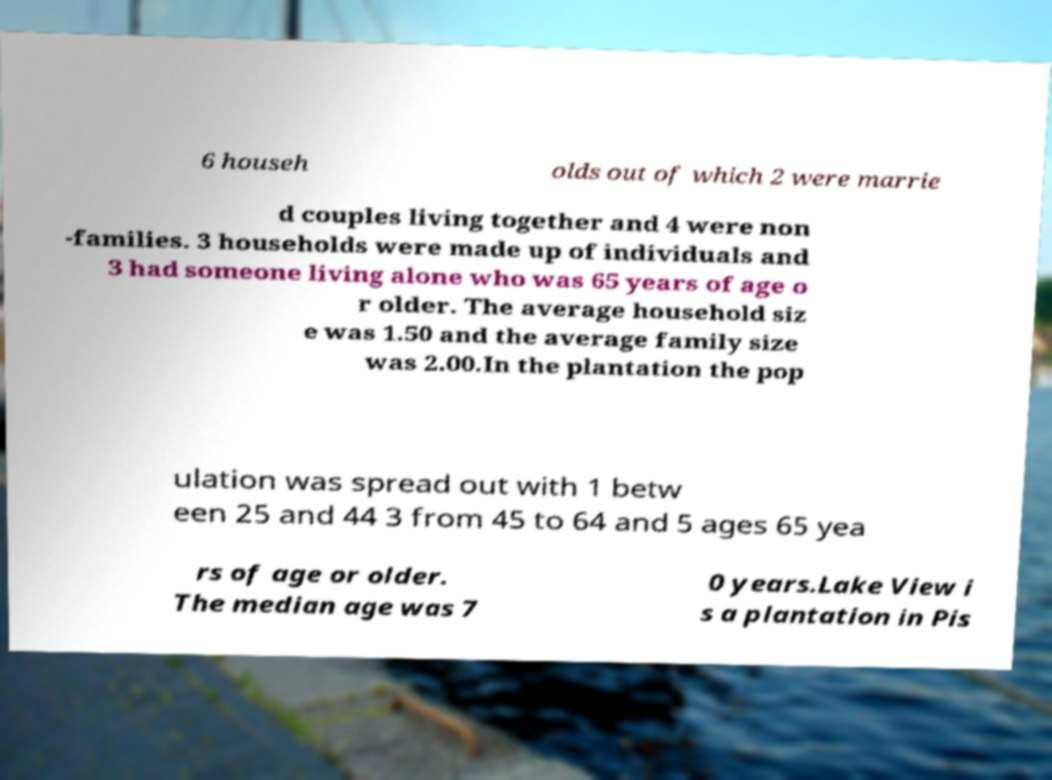Could you extract and type out the text from this image? 6 househ olds out of which 2 were marrie d couples living together and 4 were non -families. 3 households were made up of individuals and 3 had someone living alone who was 65 years of age o r older. The average household siz e was 1.50 and the average family size was 2.00.In the plantation the pop ulation was spread out with 1 betw een 25 and 44 3 from 45 to 64 and 5 ages 65 yea rs of age or older. The median age was 7 0 years.Lake View i s a plantation in Pis 